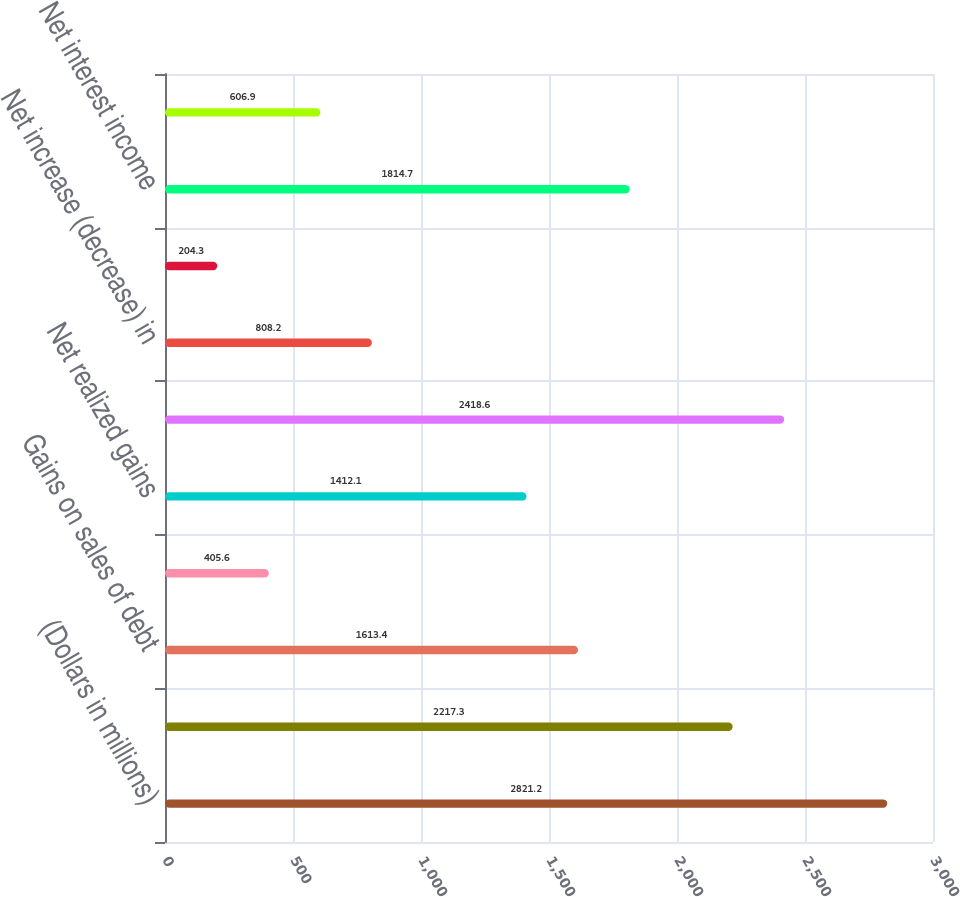Convert chart. <chart><loc_0><loc_0><loc_500><loc_500><bar_chart><fcel>(Dollars in millions)<fcel>Net increase in fair value<fcel>Gains on sales of debt<fcel>Other income<fcel>Net realized gains<fcel>Net change<fcel>Net increase (decrease) in<fcel>Net realized losses<fcel>Net interest income<fcel>Personnel<nl><fcel>2821.2<fcel>2217.3<fcel>1613.4<fcel>405.6<fcel>1412.1<fcel>2418.6<fcel>808.2<fcel>204.3<fcel>1814.7<fcel>606.9<nl></chart> 